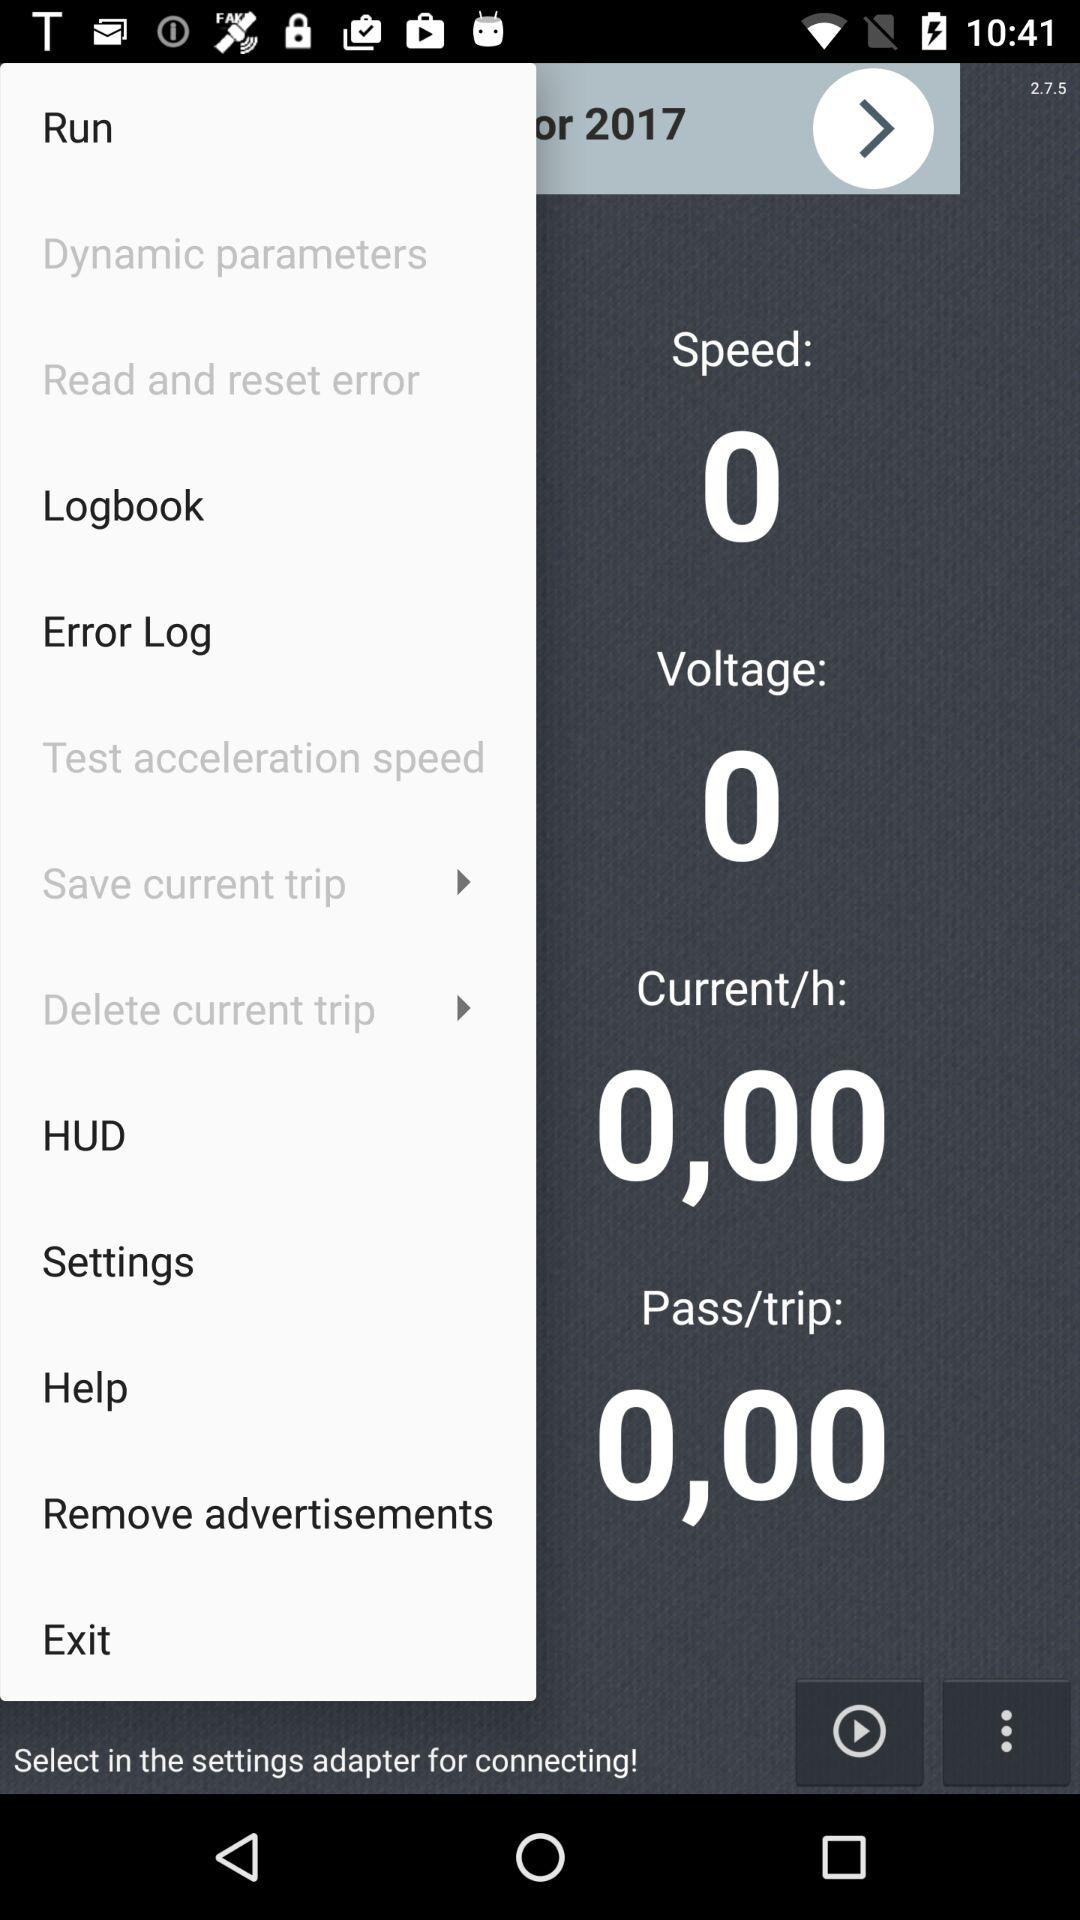What is the voltage? The voltage is 0. 